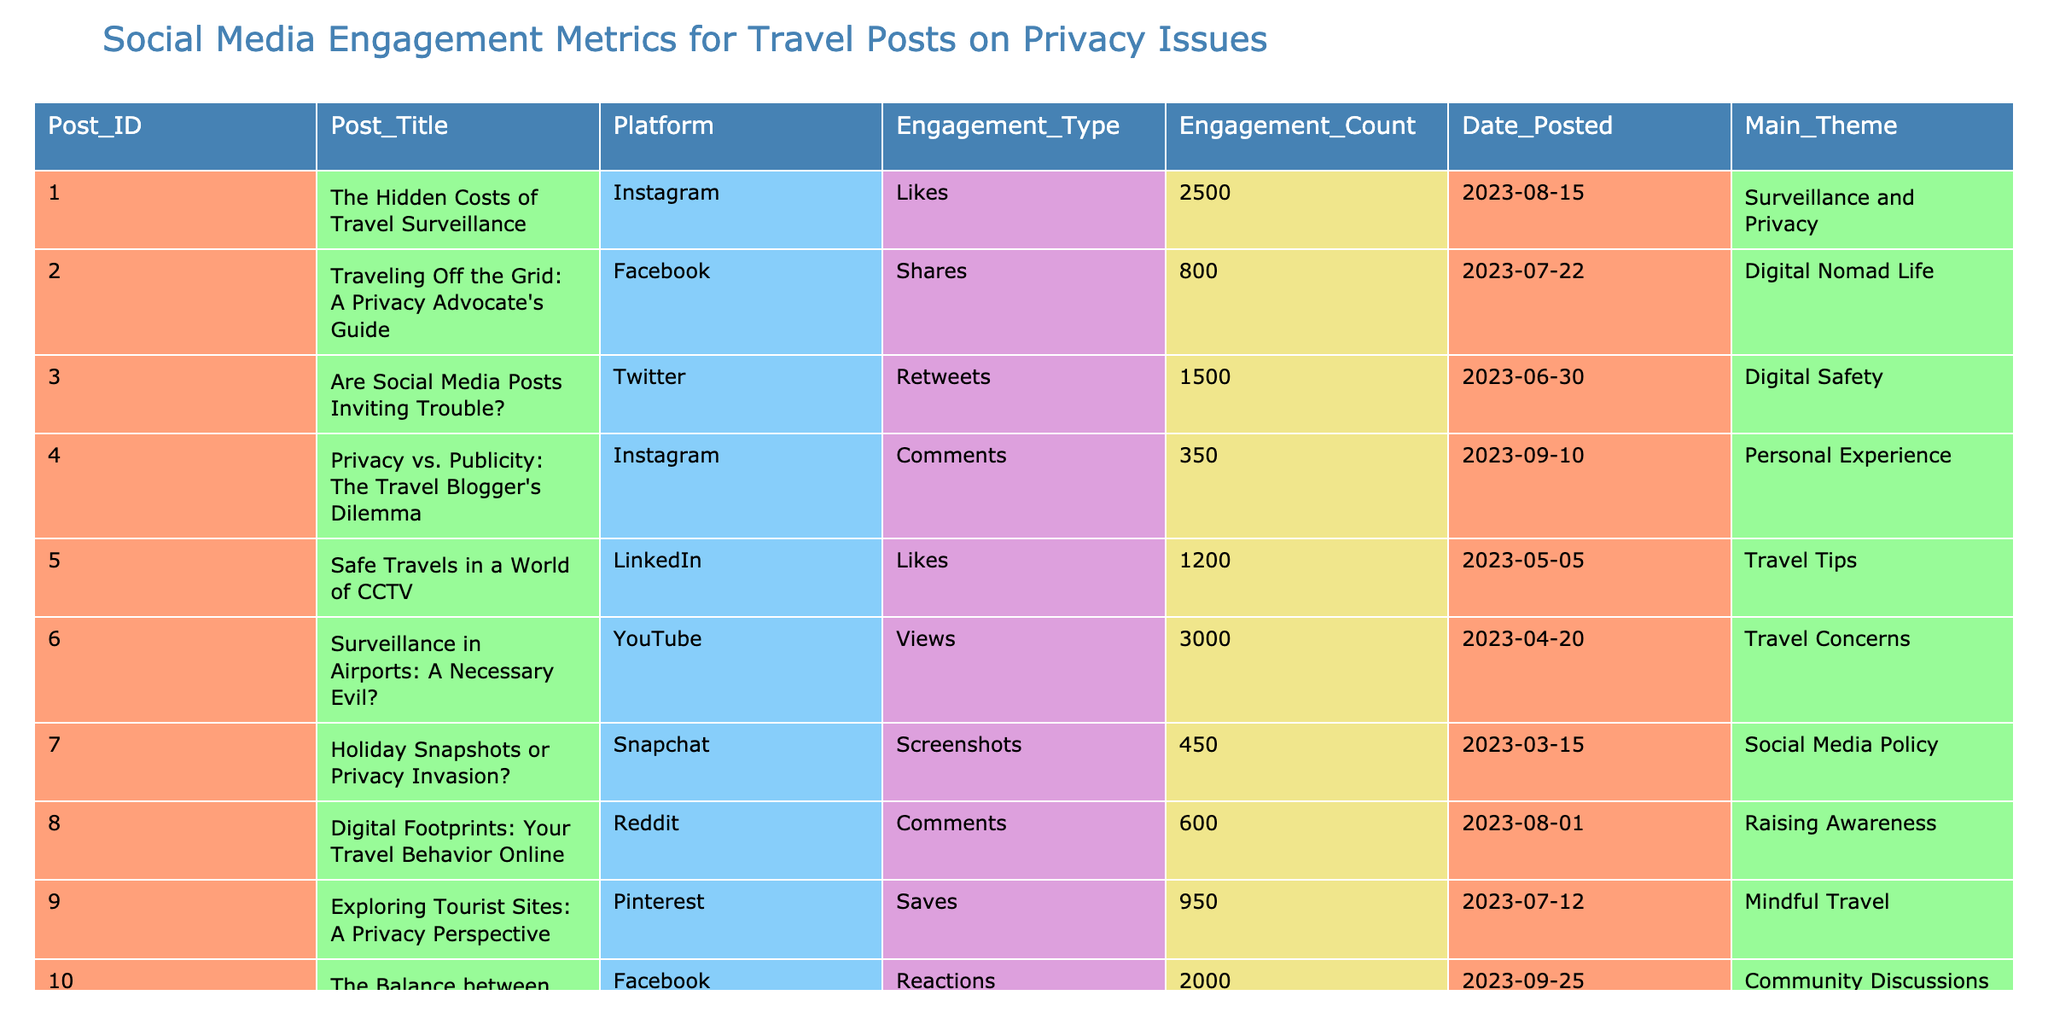What is the Post ID with the highest engagement count? Looking at the "Engagement_Count" column, the highest value is 3000, which corresponds to Post ID 006.
Answer: 006 Which platform had the most likes for privacy-related travel posts? In the table, the likes for each platform are: Instagram (2500), LinkedIn (1200), and others have different engagement types. The highest is from Instagram.
Answer: Instagram How many total engagements were recorded across all posts? Summing up the engagement counts: 2500 + 800 + 1500 + 350 + 1200 + 3000 + 450 + 600 + 950 + 2000 = 13000.
Answer: 13000 What is the average engagement count for the posts listed? The total engagement count is 13000, and there are 10 posts, so the average is 13000/10 = 1300.
Answer: 1300 Which post has the most comments, and what is the engagement count for it? Looking through the "Engagement_Type" column, the only post with comments is post 004 with an engagement count of 350.
Answer: Post ID 004, 350 Is there a post that focuses on digital safety that received more than 1500 engagements? The post titled "Are Social Media Posts Inviting Trouble?" focuses on digital safety and received 1500 engagements, which is not more than 1500.
Answer: No What is the difference in engagement counts between the post with the most views and the one with the least shares? The post with the most views is 3000 (Post ID 006), and the least shares is 800 from Post ID 002, thus the difference is 3000 - 800 = 2200.
Answer: 2200 How many posts are centered around the theme of "Surveillance and Privacy"? Scanning through the table, there are 2 posts under the "Surveillance and Privacy" theme.
Answer: 2 Which engagement type received the least attention overall based on the engagement counts? Comparing the engagement counts for all types, the least observed engagement type is "Screenshots" with 450 engagements.
Answer: Screenshots What percentage of the total engagements does the leading engagement count represent? The leading engagement count is 3000 from Post ID 006. To find the percentage: (3000 / 13000) * 100 = 23.08%.
Answer: 23.08% 